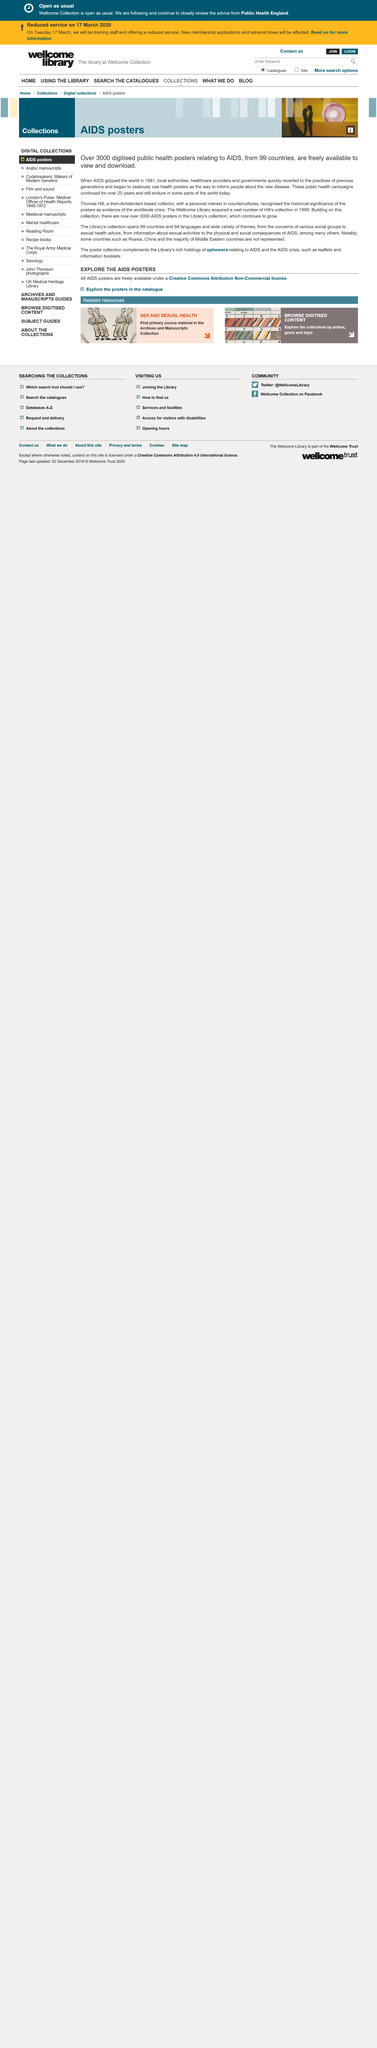Indicate a few pertinent items in this graphic. There are over 3000 public health posters available to view and download that relate to AIDS. The world was gripped by AIDS in 1981. Thomas Hill is a collector who was based in Amsterdam at the time. 